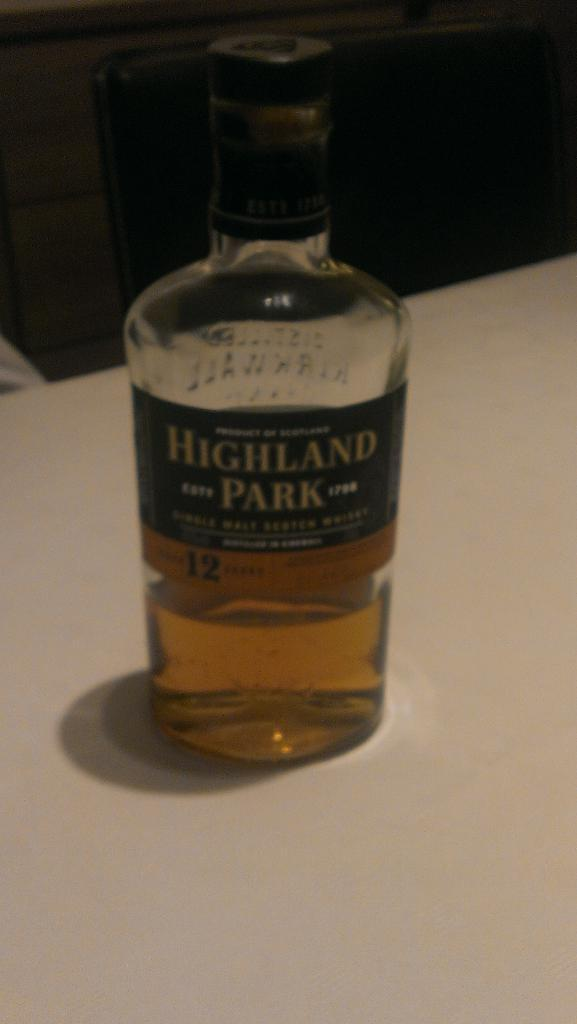<image>
Provide a brief description of the given image. An opened bottle of Highland Park alcohol on a table. 